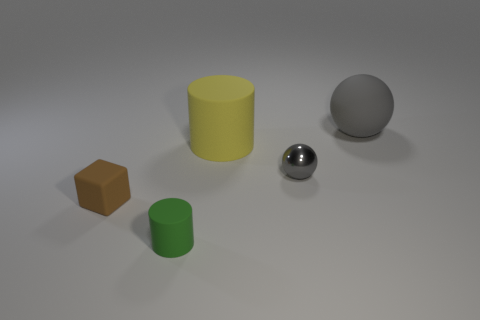There is a small object that is behind the green matte cylinder and on the left side of the yellow matte cylinder; what is its shape?
Offer a very short reply. Cube. The matte thing that is behind the big rubber thing that is in front of the rubber object that is to the right of the small gray metallic object is what shape?
Make the answer very short. Sphere. What is the thing that is behind the gray shiny ball and in front of the matte ball made of?
Your response must be concise. Rubber. How many brown rubber things are the same size as the gray rubber object?
Your answer should be very brief. 0. How many shiny things are either small green objects or yellow spheres?
Ensure brevity in your answer.  0. What material is the yellow cylinder?
Ensure brevity in your answer.  Rubber. There is a rubber cube; how many small matte things are to the right of it?
Offer a very short reply. 1. Does the sphere behind the large yellow matte thing have the same material as the brown object?
Provide a succinct answer. Yes. What number of tiny brown matte things are the same shape as the tiny green object?
Your answer should be compact. 0. How many large objects are either cyan shiny cylinders or brown objects?
Make the answer very short. 0. 